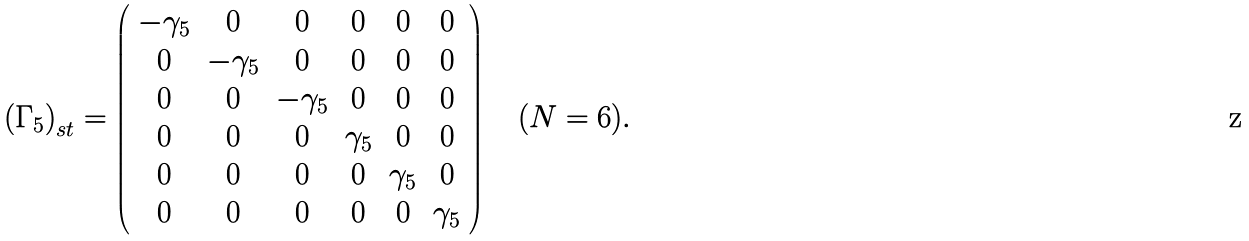<formula> <loc_0><loc_0><loc_500><loc_500>\left ( \Gamma _ { 5 } \right ) _ { s t } = \left ( \begin{array} { c c c c c c } - \gamma _ { 5 } & 0 & 0 & 0 & 0 & 0 \\ 0 & - \gamma _ { 5 } & 0 & 0 & 0 & 0 \\ 0 & 0 & - \gamma _ { 5 } & 0 & 0 & 0 \\ 0 & 0 & 0 & \gamma _ { 5 } & 0 & 0 \\ 0 & 0 & 0 & 0 & \gamma _ { 5 } & 0 \\ 0 & 0 & 0 & 0 & 0 & \gamma _ { 5 } \end{array} \right ) \quad ( N = 6 ) .</formula> 